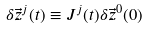<formula> <loc_0><loc_0><loc_500><loc_500>\delta \vec { z } ^ { j } ( t ) \equiv J ^ { j } ( t ) \delta \vec { z } ^ { 0 } ( 0 )</formula> 